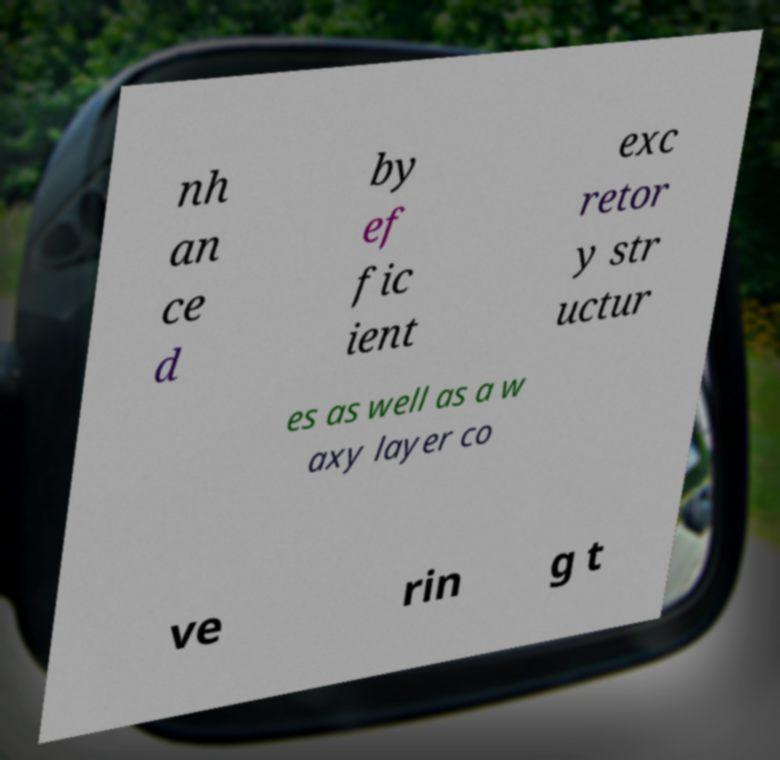Could you extract and type out the text from this image? nh an ce d by ef fic ient exc retor y str uctur es as well as a w axy layer co ve rin g t 